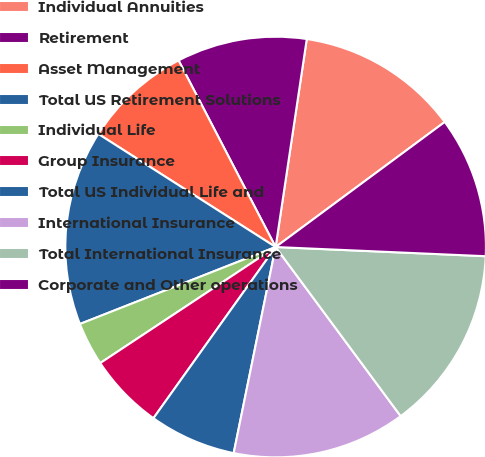Convert chart. <chart><loc_0><loc_0><loc_500><loc_500><pie_chart><fcel>Individual Annuities<fcel>Retirement<fcel>Asset Management<fcel>Total US Retirement Solutions<fcel>Individual Life<fcel>Group Insurance<fcel>Total US Individual Life and<fcel>International Insurance<fcel>Total International Insurance<fcel>Corporate and Other operations<nl><fcel>12.5%<fcel>10.0%<fcel>8.33%<fcel>15.0%<fcel>3.34%<fcel>5.83%<fcel>6.67%<fcel>13.33%<fcel>14.17%<fcel>10.83%<nl></chart> 